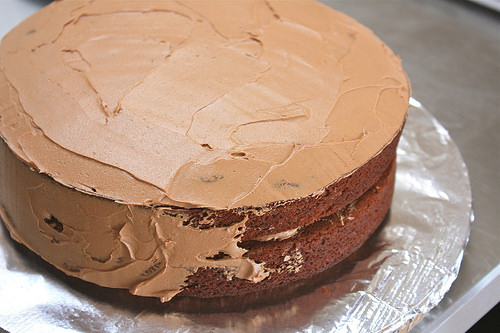<image>
Is the foil on the cake? No. The foil is not positioned on the cake. They may be near each other, but the foil is not supported by or resting on top of the cake. Is there a frosting above the cake? No. The frosting is not positioned above the cake. The vertical arrangement shows a different relationship. 